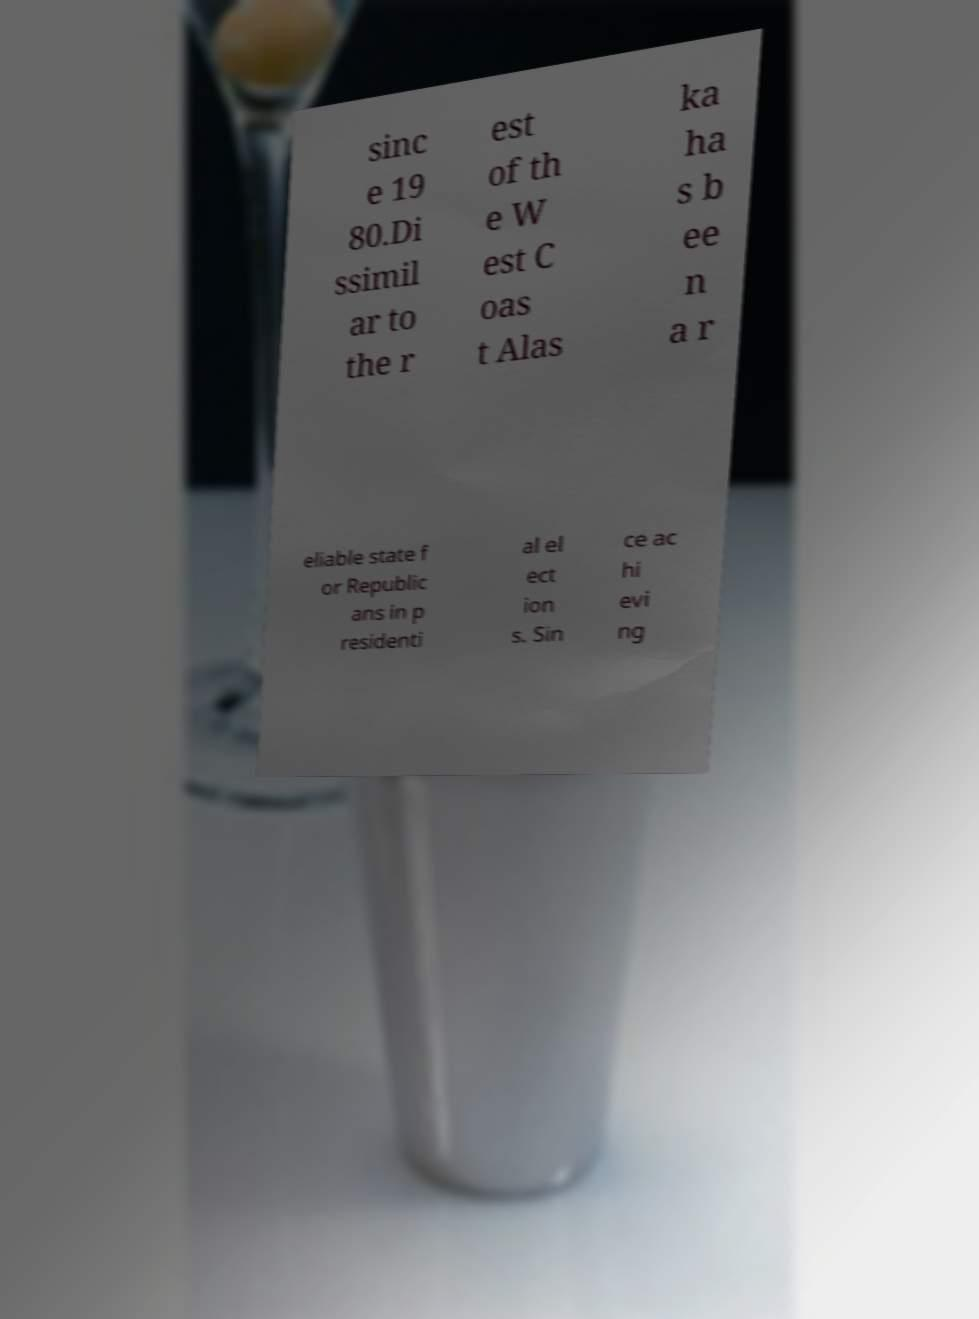Please read and relay the text visible in this image. What does it say? sinc e 19 80.Di ssimil ar to the r est of th e W est C oas t Alas ka ha s b ee n a r eliable state f or Republic ans in p residenti al el ect ion s. Sin ce ac hi evi ng 